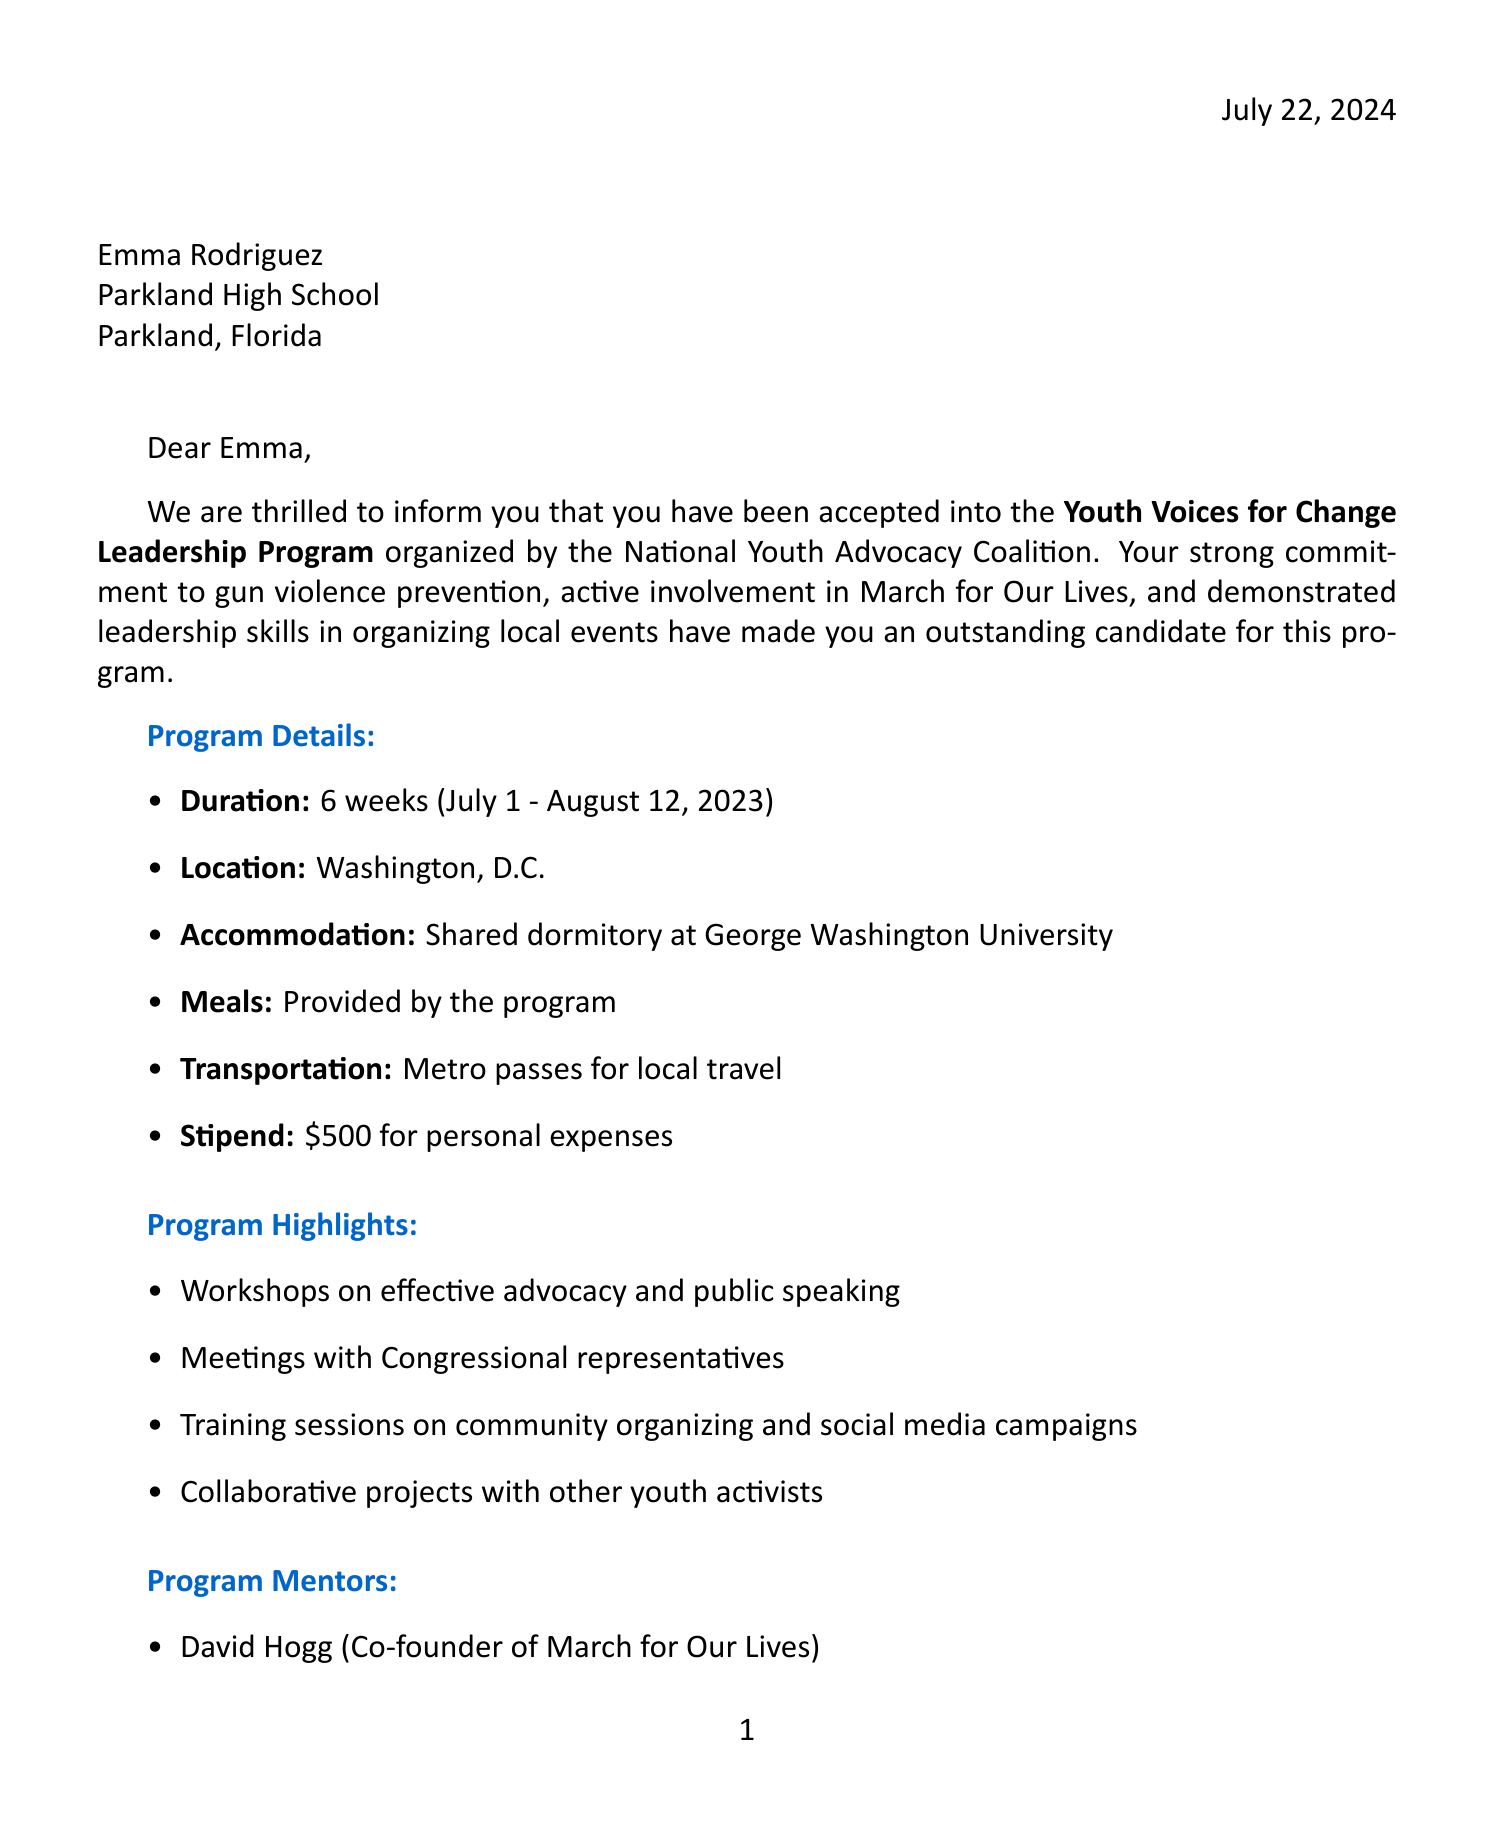What is the name of the program? The document states that the program is called the Youth Voices for Change Leadership Program.
Answer: Youth Voices for Change Leadership Program Who is the organization behind the program? The letter mentions that the program is organized by the National Youth Advocacy Coalition.
Answer: National Youth Advocacy Coalition What are the dates of the program? The program's duration is from July 1 to August 12, 2023, as specified in the document.
Answer: July 1 - August 12, 2023 Who is one of the program mentors? The document lists several mentors, including David Hogg, who is the co-founder of March for Our Lives.
Answer: David Hogg What is the stipend amount provided by the program? The letter indicates that there is a stipend of $500 for personal expenses, which can be found under logistical details.
Answer: $500 What skills will the program enhance? The expected outcomes include enhanced leadership and communication skills, which are mentioned in the document.
Answer: Leadership and communication skills What is required to be submitted by June 15, 2023? The letter states that signed parental consent form, medical insurance information, and travel itinerary are required documents due by this date.
Answer: Required documents What is the accommodation provided during the program? The document states that accommodation will be in a shared dormitory at George Washington University.
Answer: Shared dormitory at George Washington University 